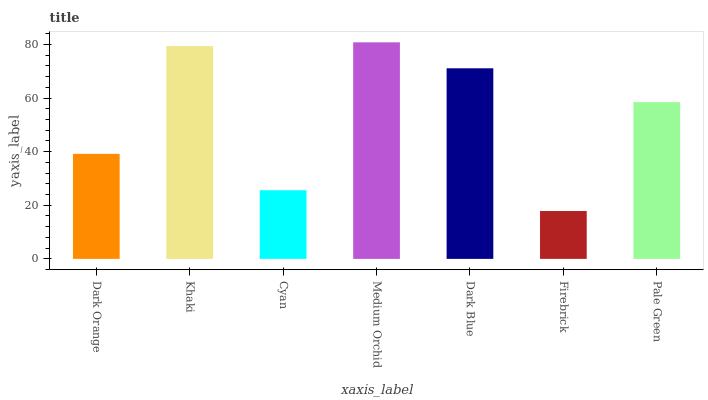Is Firebrick the minimum?
Answer yes or no. Yes. Is Medium Orchid the maximum?
Answer yes or no. Yes. Is Khaki the minimum?
Answer yes or no. No. Is Khaki the maximum?
Answer yes or no. No. Is Khaki greater than Dark Orange?
Answer yes or no. Yes. Is Dark Orange less than Khaki?
Answer yes or no. Yes. Is Dark Orange greater than Khaki?
Answer yes or no. No. Is Khaki less than Dark Orange?
Answer yes or no. No. Is Pale Green the high median?
Answer yes or no. Yes. Is Pale Green the low median?
Answer yes or no. Yes. Is Khaki the high median?
Answer yes or no. No. Is Dark Blue the low median?
Answer yes or no. No. 